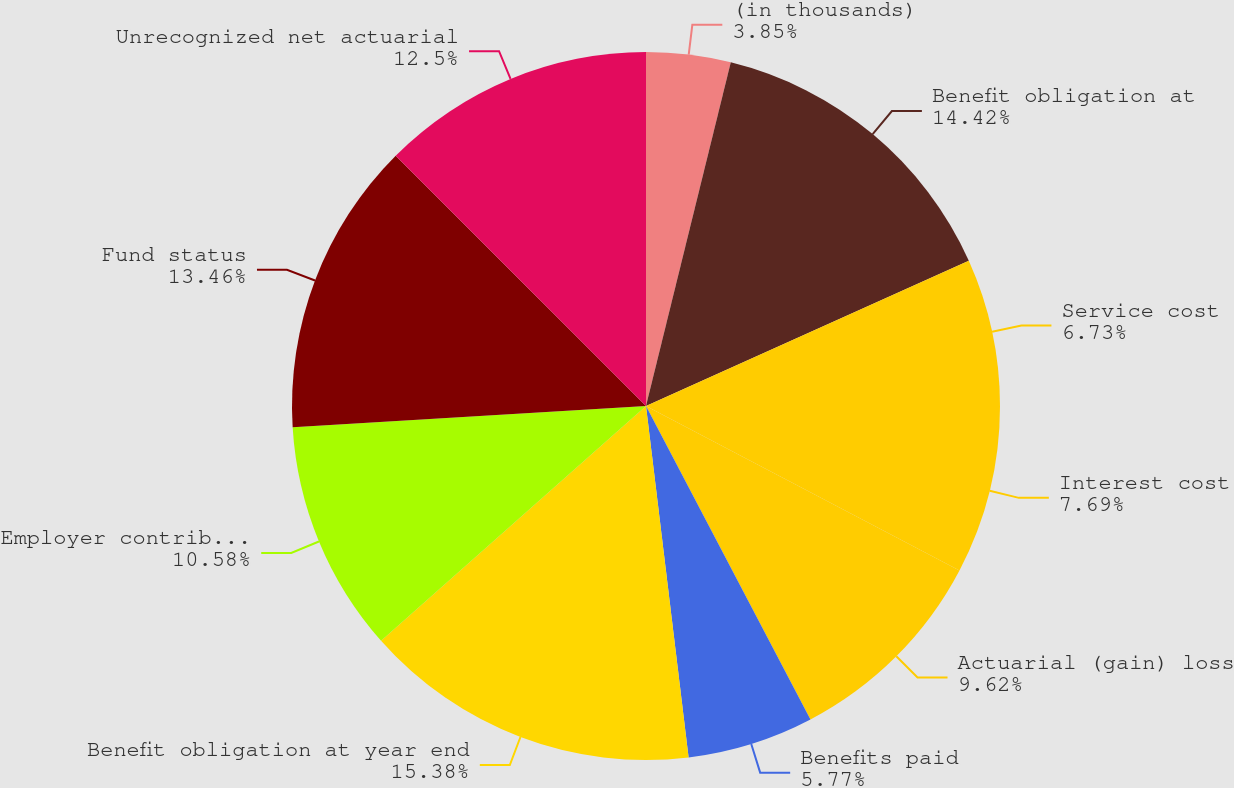<chart> <loc_0><loc_0><loc_500><loc_500><pie_chart><fcel>(in thousands)<fcel>Benefit obligation at<fcel>Service cost<fcel>Interest cost<fcel>Actuarial (gain) loss<fcel>Benefits paid<fcel>Benefit obligation at year end<fcel>Employer contribution<fcel>Fund status<fcel>Unrecognized net actuarial<nl><fcel>3.85%<fcel>14.42%<fcel>6.73%<fcel>7.69%<fcel>9.62%<fcel>5.77%<fcel>15.38%<fcel>10.58%<fcel>13.46%<fcel>12.5%<nl></chart> 